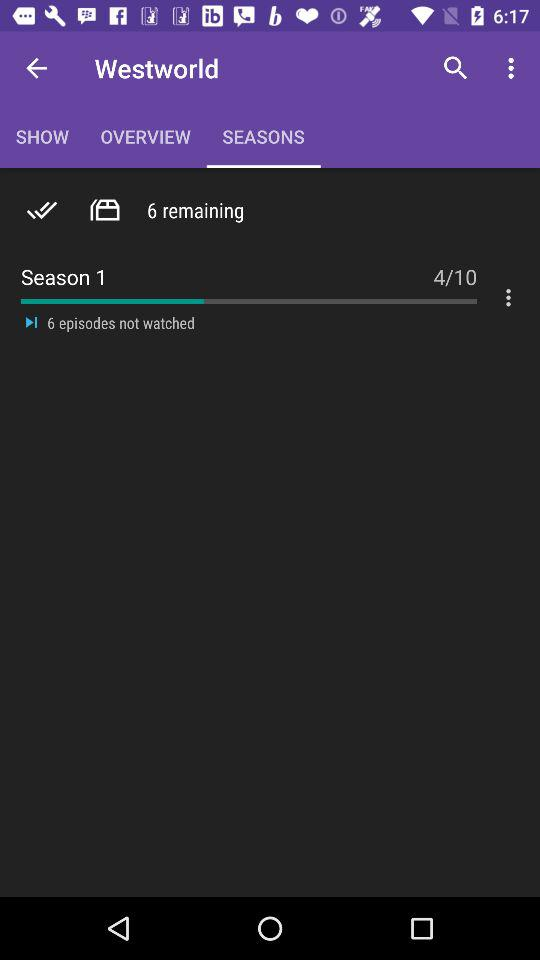How many episodes have I not watched?
Answer the question using a single word or phrase. 6 